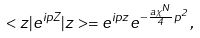Convert formula to latex. <formula><loc_0><loc_0><loc_500><loc_500>< z | e ^ { i p Z } | z > = e ^ { i p z } e ^ { - \frac { a { \chi } ^ { N } } { 4 } p ^ { 2 } } ,</formula> 